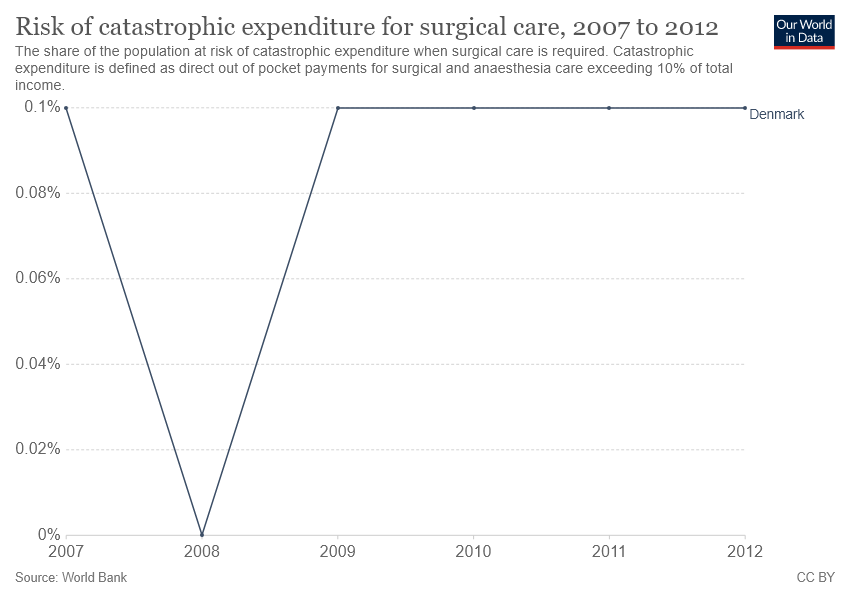Give some essential details in this illustration. The given line graph represents a country that is Denmark. The year 2008 experienced the highest decrease in the incidence of catastrophic expenditure for surgical care, as compared to other years. 